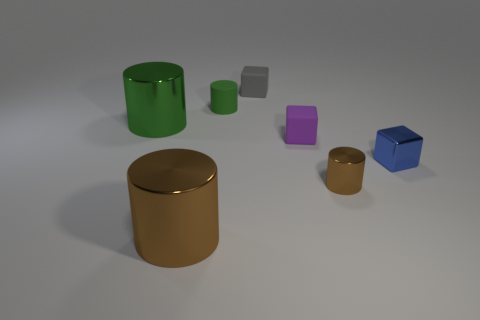Add 3 brown cylinders. How many objects exist? 10 Subtract all cubes. How many objects are left? 4 Subtract 1 purple cubes. How many objects are left? 6 Subtract all tiny blue cylinders. Subtract all tiny blue things. How many objects are left? 6 Add 6 big green objects. How many big green objects are left? 7 Add 1 big green things. How many big green things exist? 2 